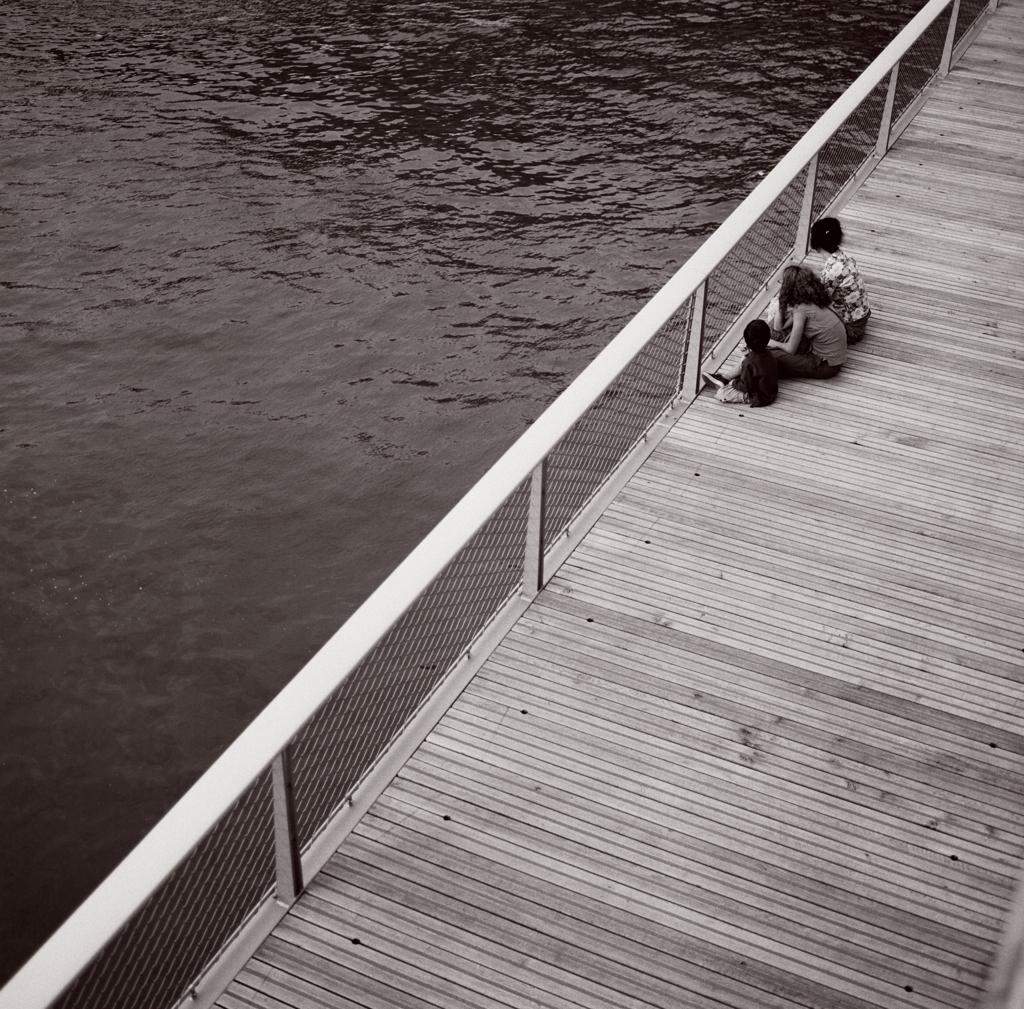What is the color scheme of the image? The image is black and white. Where are the three persons located in the image? The three persons are sitting on a bridge, which is on the right side of the image. What is in front of the people on the bridge? There is a railing in front of the people. What can be seen on the left side of the image? There is water visible on the left side of the image. How many kittens are playing with a necklace on the bridge in the image? There are no kittens or necklaces present in the image; it features three persons sitting on a bridge with a railing in front of them. What type of trade is being conducted on the bridge in the image? There is no trade being conducted in the image; it simply shows three persons sitting on a bridge. 